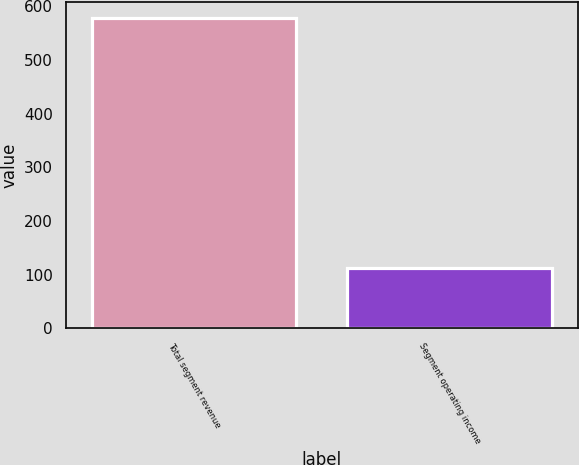<chart> <loc_0><loc_0><loc_500><loc_500><bar_chart><fcel>Total segment revenue<fcel>Segment operating income<nl><fcel>579<fcel>113<nl></chart> 